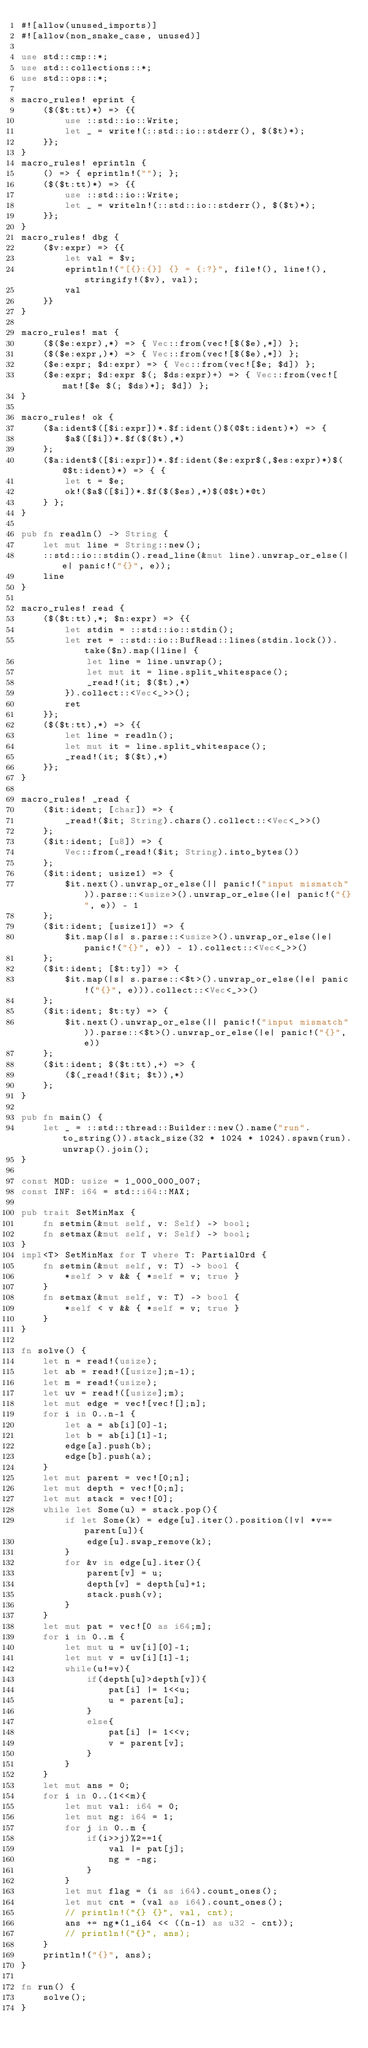<code> <loc_0><loc_0><loc_500><loc_500><_Rust_>#![allow(unused_imports)]
#![allow(non_snake_case, unused)]

use std::cmp::*;
use std::collections::*;
use std::ops::*;

macro_rules! eprint {
	($($t:tt)*) => {{
		use ::std::io::Write;
		let _ = write!(::std::io::stderr(), $($t)*);
	}};
}
macro_rules! eprintln {
	() => { eprintln!(""); };
	($($t:tt)*) => {{
		use ::std::io::Write;
		let _ = writeln!(::std::io::stderr(), $($t)*);
	}};
}
macro_rules! dbg {
	($v:expr) => {{
		let val = $v;
		eprintln!("[{}:{}] {} = {:?}", file!(), line!(), stringify!($v), val);
		val
	}}
}

macro_rules! mat {
	($($e:expr),*) => { Vec::from(vec![$($e),*]) };
	($($e:expr,)*) => { Vec::from(vec![$($e),*]) };
	($e:expr; $d:expr) => { Vec::from(vec![$e; $d]) };
	($e:expr; $d:expr $(; $ds:expr)+) => { Vec::from(vec![mat![$e $(; $ds)*]; $d]) };
}

macro_rules! ok {
	($a:ident$([$i:expr])*.$f:ident()$(@$t:ident)*) => {
		$a$([$i])*.$f($($t),*)
	};
	($a:ident$([$i:expr])*.$f:ident($e:expr$(,$es:expr)*)$(@$t:ident)*) => { {
		let t = $e;
		ok!($a$([$i])*.$f($($es),*)$(@$t)*@t)
	} };
}

pub fn readln() -> String {
	let mut line = String::new();
	::std::io::stdin().read_line(&mut line).unwrap_or_else(|e| panic!("{}", e));
	line
}

macro_rules! read {
	($($t:tt),*; $n:expr) => {{
		let stdin = ::std::io::stdin();
		let ret = ::std::io::BufRead::lines(stdin.lock()).take($n).map(|line| {
			let line = line.unwrap();
			let mut it = line.split_whitespace();
			_read!(it; $($t),*)
		}).collect::<Vec<_>>();
		ret
	}};
	($($t:tt),*) => {{
		let line = readln();
		let mut it = line.split_whitespace();
		_read!(it; $($t),*)
	}};
}

macro_rules! _read {
	($it:ident; [char]) => {
		_read!($it; String).chars().collect::<Vec<_>>()
	};
	($it:ident; [u8]) => {
		Vec::from(_read!($it; String).into_bytes())
	};
	($it:ident; usize1) => {
		$it.next().unwrap_or_else(|| panic!("input mismatch")).parse::<usize>().unwrap_or_else(|e| panic!("{}", e)) - 1
	};
	($it:ident; [usize1]) => {
		$it.map(|s| s.parse::<usize>().unwrap_or_else(|e| panic!("{}", e)) - 1).collect::<Vec<_>>()
	};
	($it:ident; [$t:ty]) => {
		$it.map(|s| s.parse::<$t>().unwrap_or_else(|e| panic!("{}", e))).collect::<Vec<_>>()
	};
	($it:ident; $t:ty) => {
		$it.next().unwrap_or_else(|| panic!("input mismatch")).parse::<$t>().unwrap_or_else(|e| panic!("{}", e))
	};
	($it:ident; $($t:tt),+) => {
		($(_read!($it; $t)),*)
	};
}

pub fn main() {
	let _ = ::std::thread::Builder::new().name("run".to_string()).stack_size(32 * 1024 * 1024).spawn(run).unwrap().join();
}

const MOD: usize = 1_000_000_007;
const INF: i64 = std::i64::MAX;

pub trait SetMinMax {
	fn setmin(&mut self, v: Self) -> bool;
	fn setmax(&mut self, v: Self) -> bool;
}
impl<T> SetMinMax for T where T: PartialOrd {
	fn setmin(&mut self, v: T) -> bool {
		*self > v && { *self = v; true }
	}
	fn setmax(&mut self, v: T) -> bool {
		*self < v && { *self = v; true }
	}
}

fn solve() {
	let n = read!(usize);
	let ab = read!([usize];n-1);
	let m = read!(usize);
	let uv = read!([usize];m);
	let mut edge = vec![vec![];n];
	for i in 0..n-1 {
		let a = ab[i][0]-1;
		let b = ab[i][1]-1;
		edge[a].push(b);
		edge[b].push(a);
	}
	let mut parent = vec![0;n];
	let mut depth = vec![0;n];
	let mut stack = vec![0];
	while let Some(u) = stack.pop(){
		if let Some(k) = edge[u].iter().position(|v| *v==parent[u]){
			edge[u].swap_remove(k);
		}
		for &v in edge[u].iter(){
			parent[v] = u;
			depth[v] = depth[u]+1;
			stack.push(v);
		}
	}
	let mut pat = vec![0 as i64;m];
	for i in 0..m {
		let mut u = uv[i][0]-1;
		let mut v = uv[i][1]-1;
		while(u!=v){
			if(depth[u]>depth[v]){
				pat[i] |= 1<<u;
				u = parent[u];
			}
			else{
				pat[i] |= 1<<v;
				v = parent[v];
			}
		}
	}
	let mut ans = 0;
	for i in 0..(1<<m){
		let mut val: i64 = 0;
		let mut ng: i64 = 1;
		for j in 0..m {
			if(i>>j)%2==1{
				val |= pat[j];
				ng = -ng;
			}
		}
		let mut flag = (i as i64).count_ones();
		let mut cnt = (val as i64).count_ones();
		// println!("{} {}", val, cnt);
		ans += ng*(1_i64 << ((n-1) as u32 - cnt));
		// println!("{}", ans);
	}
	println!("{}", ans);
}

fn run() {
    solve();
}</code> 